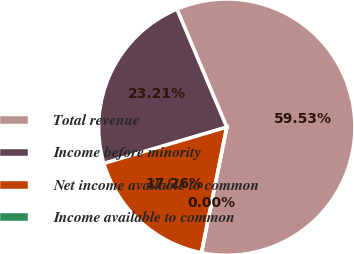Convert chart. <chart><loc_0><loc_0><loc_500><loc_500><pie_chart><fcel>Total revenue<fcel>Income before minority<fcel>Net income available to common<fcel>Income available to common<nl><fcel>59.53%<fcel>23.21%<fcel>17.26%<fcel>0.0%<nl></chart> 